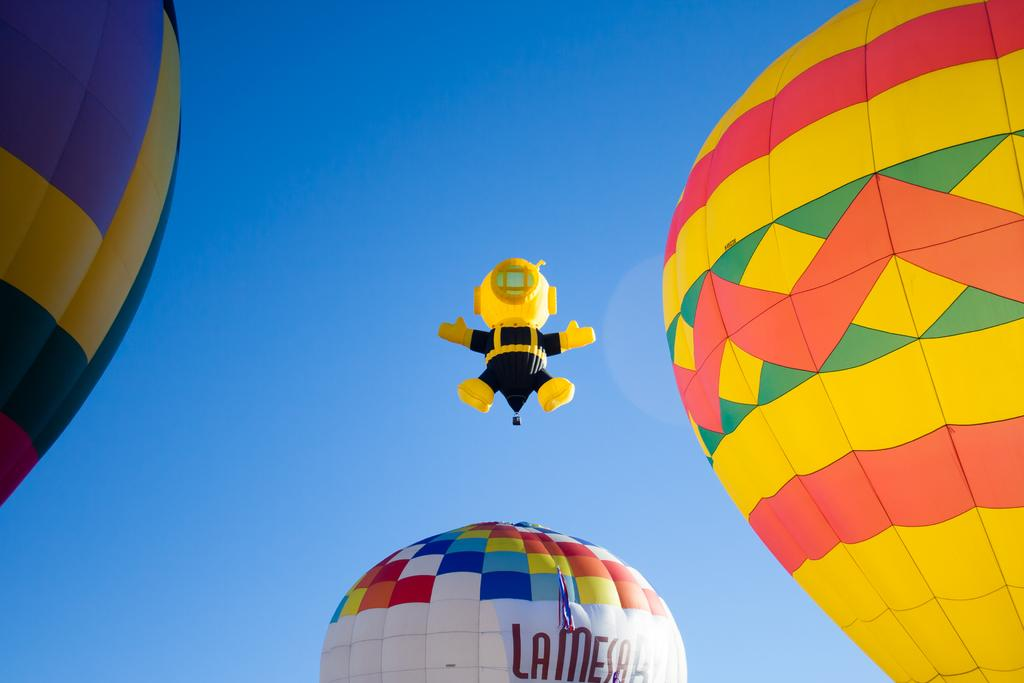<image>
Provide a brief description of the given image. A series of hot air balloons in the sky, one of which is advertising La Mesa. 